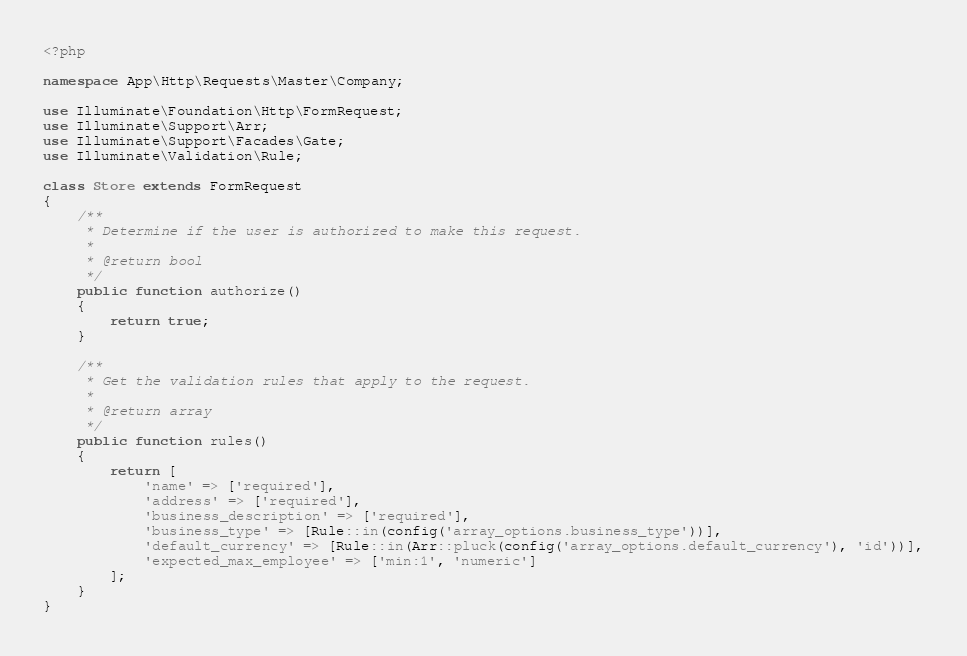<code> <loc_0><loc_0><loc_500><loc_500><_PHP_><?php

namespace App\Http\Requests\Master\Company;

use Illuminate\Foundation\Http\FormRequest;
use Illuminate\Support\Arr;
use Illuminate\Support\Facades\Gate;
use Illuminate\Validation\Rule;

class Store extends FormRequest
{
    /**
     * Determine if the user is authorized to make this request.
     *
     * @return bool
     */
    public function authorize()
    {
        return true;
    }

    /**
     * Get the validation rules that apply to the request.
     *
     * @return array
     */
    public function rules()
    {
        return [
            'name' => ['required'],
            'address' => ['required'],
            'business_description' => ['required'],
            'business_type' => [Rule::in(config('array_options.business_type'))],
            'default_currency' => [Rule::in(Arr::pluck(config('array_options.default_currency'), 'id'))],
            'expected_max_employee' => ['min:1', 'numeric']
        ];
    }
}

</code> 